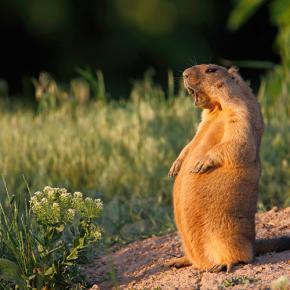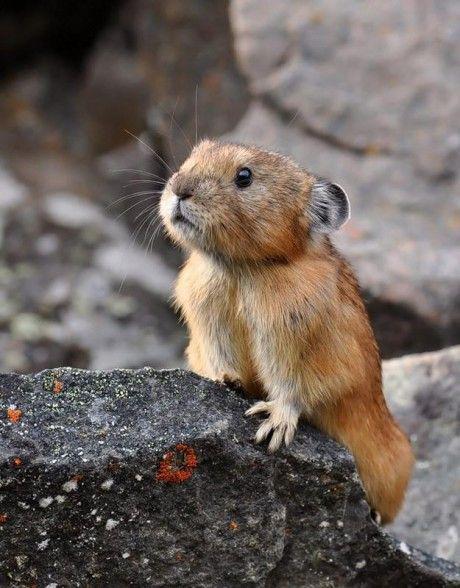The first image is the image on the left, the second image is the image on the right. Evaluate the accuracy of this statement regarding the images: "There are our groundhogs.". Is it true? Answer yes or no. No. The first image is the image on the left, the second image is the image on the right. Assess this claim about the two images: "One image shows at least two marmots standing up and facing towards each other, with their front paws hanging down.". Correct or not? Answer yes or no. No. 